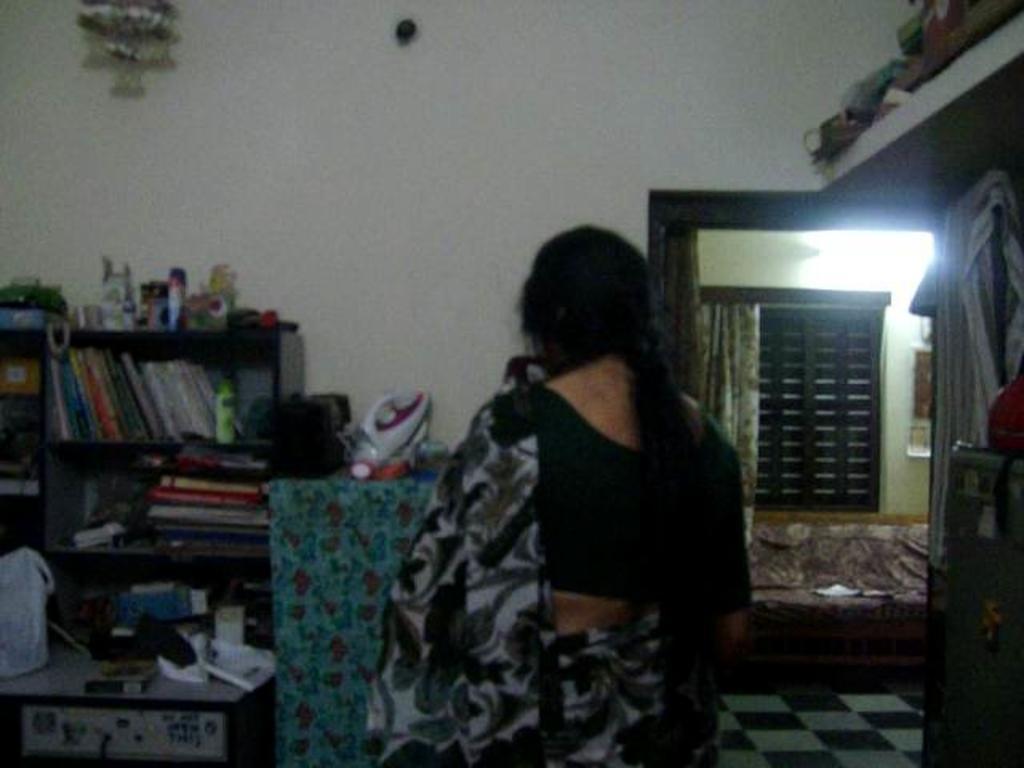Can you describe this image briefly? In the center of the image we can see a lady standing. On the left there is a stand and we can see books and some objects placed in the stand. On the right there is a refrigerator. In the background there is a door, window, curtain and a bed. There is a shelf and we can see a decor. 